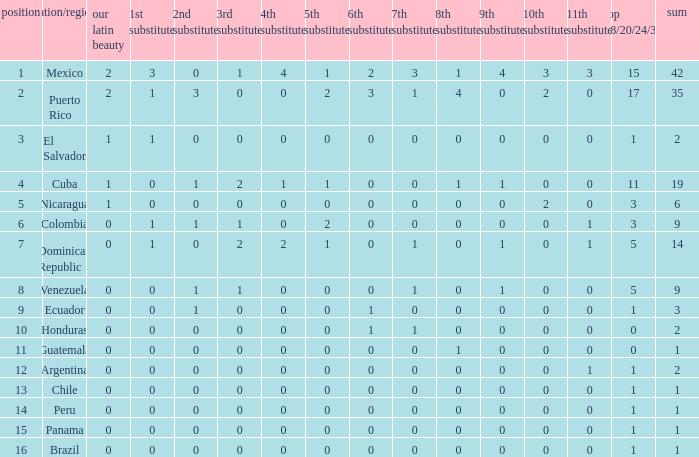What is the lowest 7th runner-up of the country with a top 18/20/24/30 greater than 5, a 1st runner-up greater than 0, and an 11th runner-up less than 0? None. 